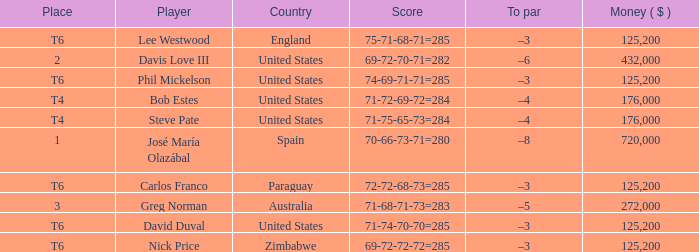Which Score has a Place of t6, and a Country of paraguay? 72-72-68-73=285. 